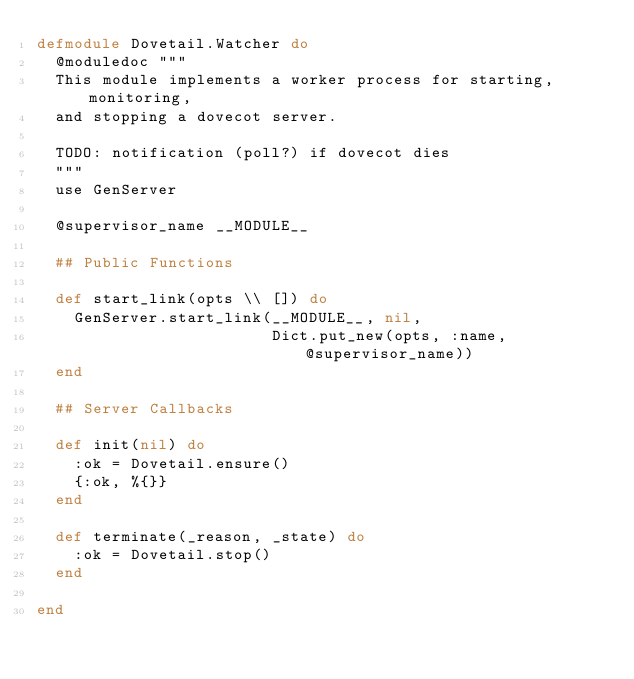Convert code to text. <code><loc_0><loc_0><loc_500><loc_500><_Elixir_>defmodule Dovetail.Watcher do
  @moduledoc """
  This module implements a worker process for starting, monitoring,
  and stopping a dovecot server.

  TODO: notification (poll?) if dovecot dies
  """
  use GenServer

  @supervisor_name __MODULE__

  ## Public Functions

  def start_link(opts \\ []) do
    GenServer.start_link(__MODULE__, nil,
                         Dict.put_new(opts, :name, @supervisor_name))
  end

  ## Server Callbacks

  def init(nil) do
    :ok = Dovetail.ensure()
    {:ok, %{}}
  end

  def terminate(_reason, _state) do
    :ok = Dovetail.stop()
  end

end
</code> 